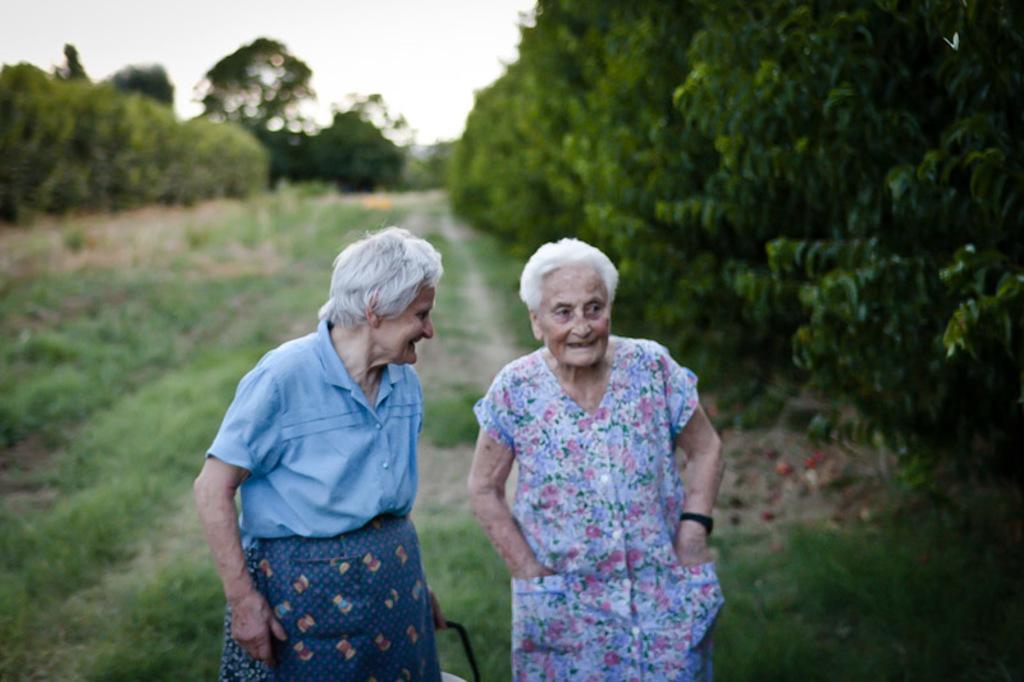Can you describe this image briefly? In the center of the image there are two women's. In the background of the image there are trees. At the bottom of the image there is grass. 